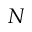<formula> <loc_0><loc_0><loc_500><loc_500>N</formula> 